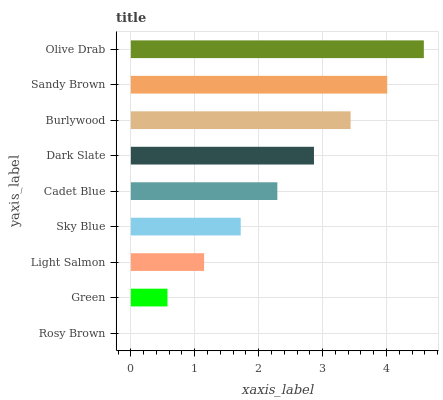Is Rosy Brown the minimum?
Answer yes or no. Yes. Is Olive Drab the maximum?
Answer yes or no. Yes. Is Green the minimum?
Answer yes or no. No. Is Green the maximum?
Answer yes or no. No. Is Green greater than Rosy Brown?
Answer yes or no. Yes. Is Rosy Brown less than Green?
Answer yes or no. Yes. Is Rosy Brown greater than Green?
Answer yes or no. No. Is Green less than Rosy Brown?
Answer yes or no. No. Is Cadet Blue the high median?
Answer yes or no. Yes. Is Cadet Blue the low median?
Answer yes or no. Yes. Is Light Salmon the high median?
Answer yes or no. No. Is Sky Blue the low median?
Answer yes or no. No. 